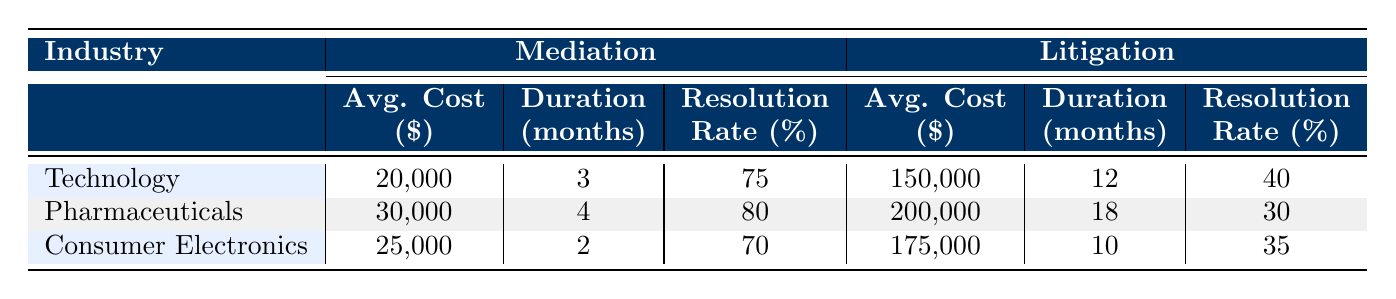What is the average cost for patent disputes in the technology industry through mediation? According to the table, under the technology industry for mediation, the average cost is listed as 20,000.
Answer: 20,000 What is the resolution rate for patent disputes in the pharmaceuticals industry through litigation? The table indicates that the resolution rate for litigation in the pharmaceuticals industry is 30 percent.
Answer: 30 How much more does litigation cost on average than mediation in the consumer electronics industry? In consumer electronics, the average cost for mediation is 25,000, while for litigation, it is 175,000. The difference is calculated as 175,000 - 25,000, which equals 150,000.
Answer: 150,000 Is the duration of mediation shorter than that of litigation across all industries shown? The table shows that for mediation, the average durations are 3 months, 4 months, and 2 months for technology, pharmaceuticals, and consumer electronics respectively. For litigation, the durations are 12 months, 18 months, and 10 months, indicating that mediation is indeed shorter than litigation in all cases.
Answer: Yes What is the average resolution rate for mediation across all industries? To find the average resolution rate for mediation, we add the resolution rates from each industry: 75 + 80 + 70 = 225. Then, divide by the number of industries, which is 3. Hence, 225 / 3 equals 75.
Answer: 75 Which case type has a higher average cost in the technology industry? The average cost for mediation in the technology industry is 20,000, whereas for litigation it is 150,000. Since 150,000 is greater than 20,000, litigation has a higher average cost.
Answer: Litigation What is the combined average duration of mediation in the technologies and consumer electronics industries? For technology, the mediation duration is 3 months, and for consumer electronics, it is 2 months. We sum these durations, which is 3 + 2 = 5 months. The average combined duration would be 5 / 2 = 2.5 months.
Answer: 2.5 months Does mediation in pharmaceuticals take longer than litigation in consumer electronics? The duration for mediation in pharmaceuticals is 4 months, while the duration for litigation in consumer electronics is 10 months. Since 4 months is less than 10 months, mediation does not take longer.
Answer: No 